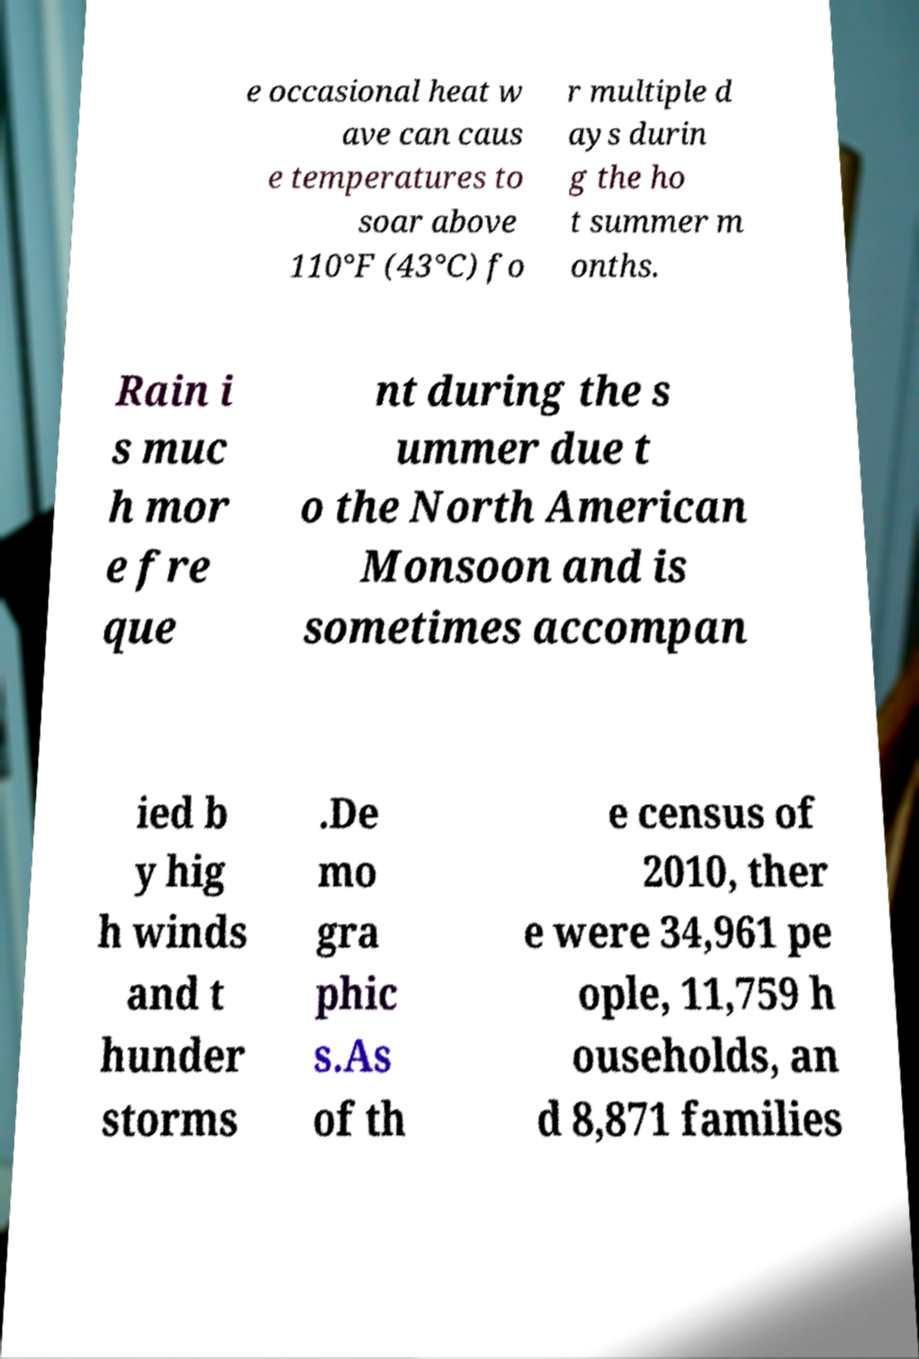Could you assist in decoding the text presented in this image and type it out clearly? e occasional heat w ave can caus e temperatures to soar above 110°F (43°C) fo r multiple d ays durin g the ho t summer m onths. Rain i s muc h mor e fre que nt during the s ummer due t o the North American Monsoon and is sometimes accompan ied b y hig h winds and t hunder storms .De mo gra phic s.As of th e census of 2010, ther e were 34,961 pe ople, 11,759 h ouseholds, an d 8,871 families 